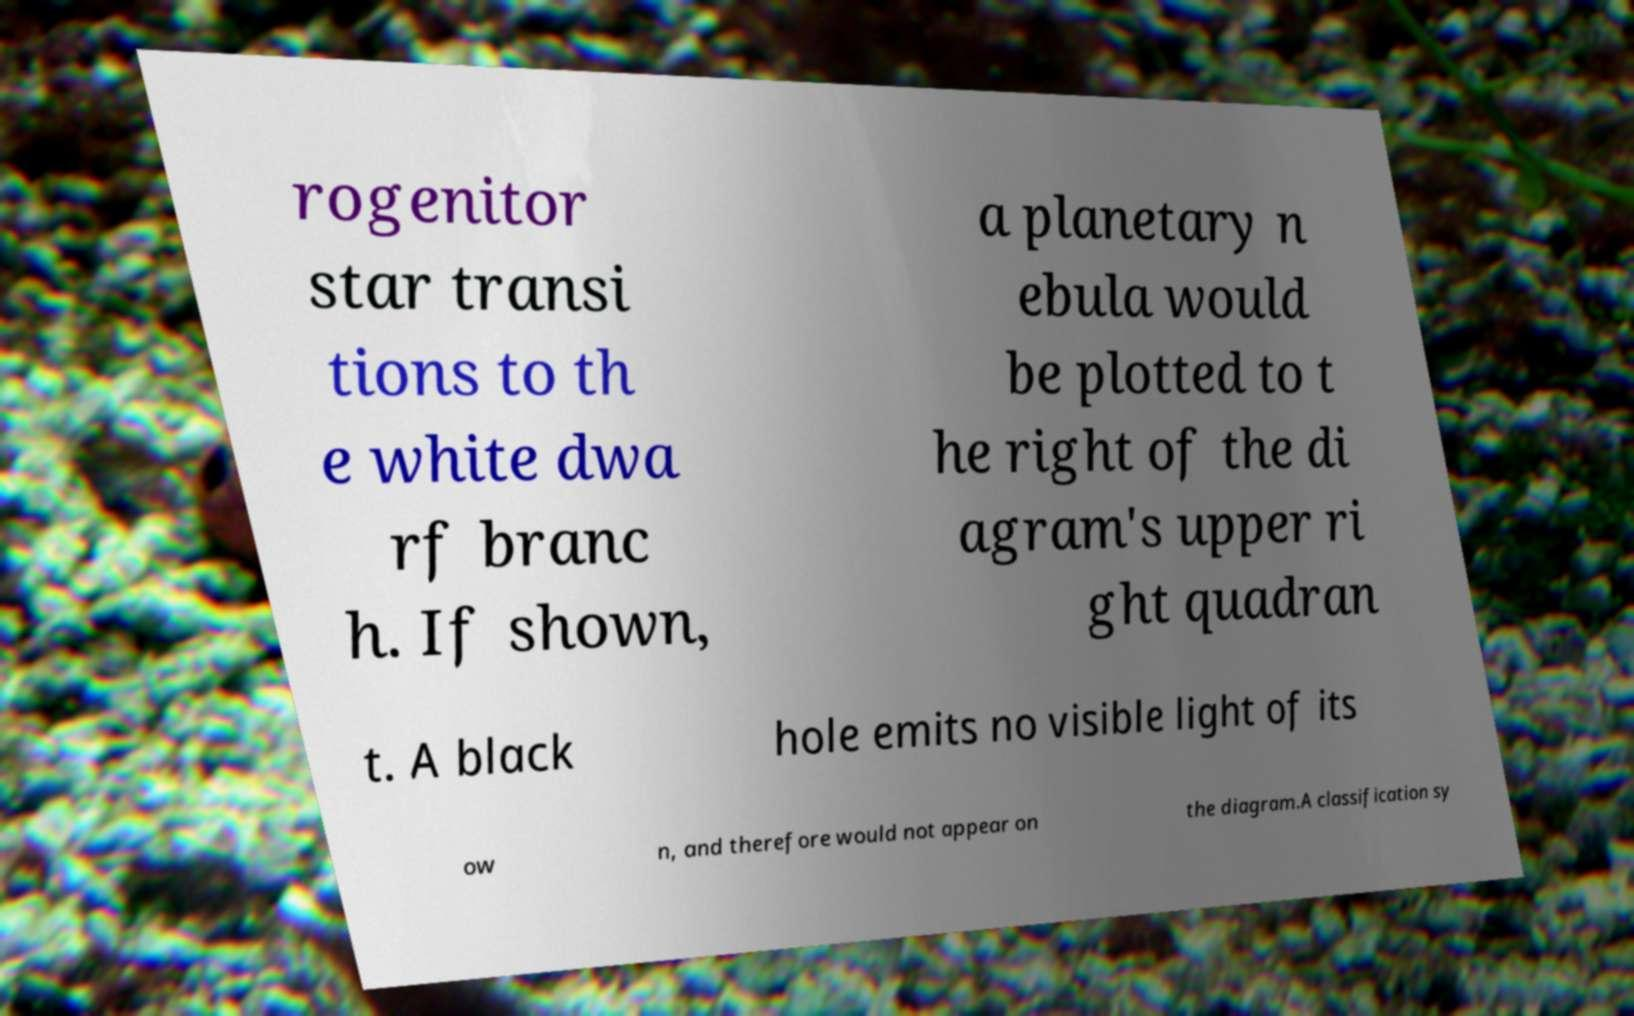For documentation purposes, I need the text within this image transcribed. Could you provide that? rogenitor star transi tions to th e white dwa rf branc h. If shown, a planetary n ebula would be plotted to t he right of the di agram's upper ri ght quadran t. A black hole emits no visible light of its ow n, and therefore would not appear on the diagram.A classification sy 